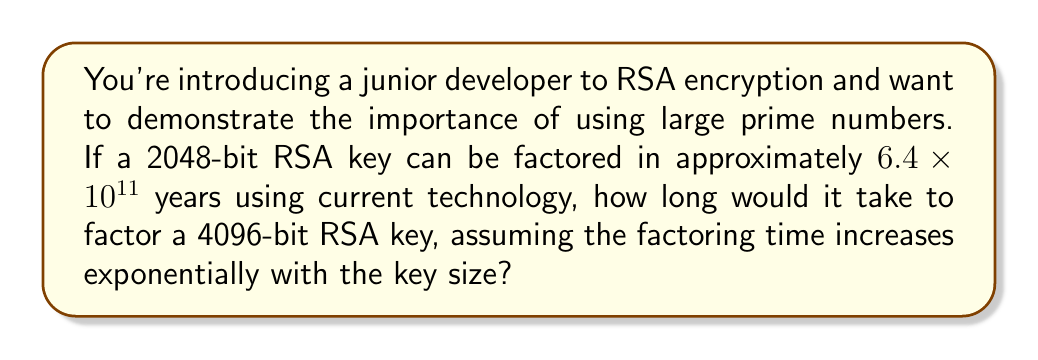Give your solution to this math problem. Let's approach this step-by-step:

1) First, we need to understand the relationship between key size and factoring time. In RSA, the factoring time increases exponentially with the key size.

2) Let's define some variables:
   $t_1$ = time to factor 2048-bit key = 6.4 × 10^11 years
   $t_2$ = time to factor 4096-bit key (what we're solving for)
   $k_1$ = 2048 bits
   $k_2$ = 4096 bits

3) The exponential relationship can be expressed as:

   $$t = c \cdot 2^k$$

   where $c$ is a constant and $k$ is the key size in bits.

4) We can set up two equations:

   $$t_1 = c \cdot 2^{k_1}$$
   $$t_2 = c \cdot 2^{k_2}$$

5) Dividing $t_2$ by $t_1$:

   $$\frac{t_2}{t_1} = \frac{c \cdot 2^{k_2}}{c \cdot 2^{k_1}} = 2^{k_2 - k_1} = 2^{4096 - 2048} = 2^{2048}$$

6) Therefore:

   $$t_2 = t_1 \cdot 2^{2048}$$

7) Plugging in the known value for $t_1$:

   $$t_2 = (6.4 \times 10^{11}) \cdot 2^{2048}$$

8) $2^{2048}$ is an enormously large number. We can approximate it as:

   $$2^{2048} \approx 3.23 \times 10^{616}$$

9) Calculating the final result:

   $$t_2 \approx (6.4 \times 10^{11}) \cdot (3.23 \times 10^{616}) \approx 2.07 \times 10^{628} \text{ years}$$

This demonstrates the immense increase in security when doubling the key size from 2048 to 4096 bits.
Answer: $2.07 \times 10^{628}$ years 